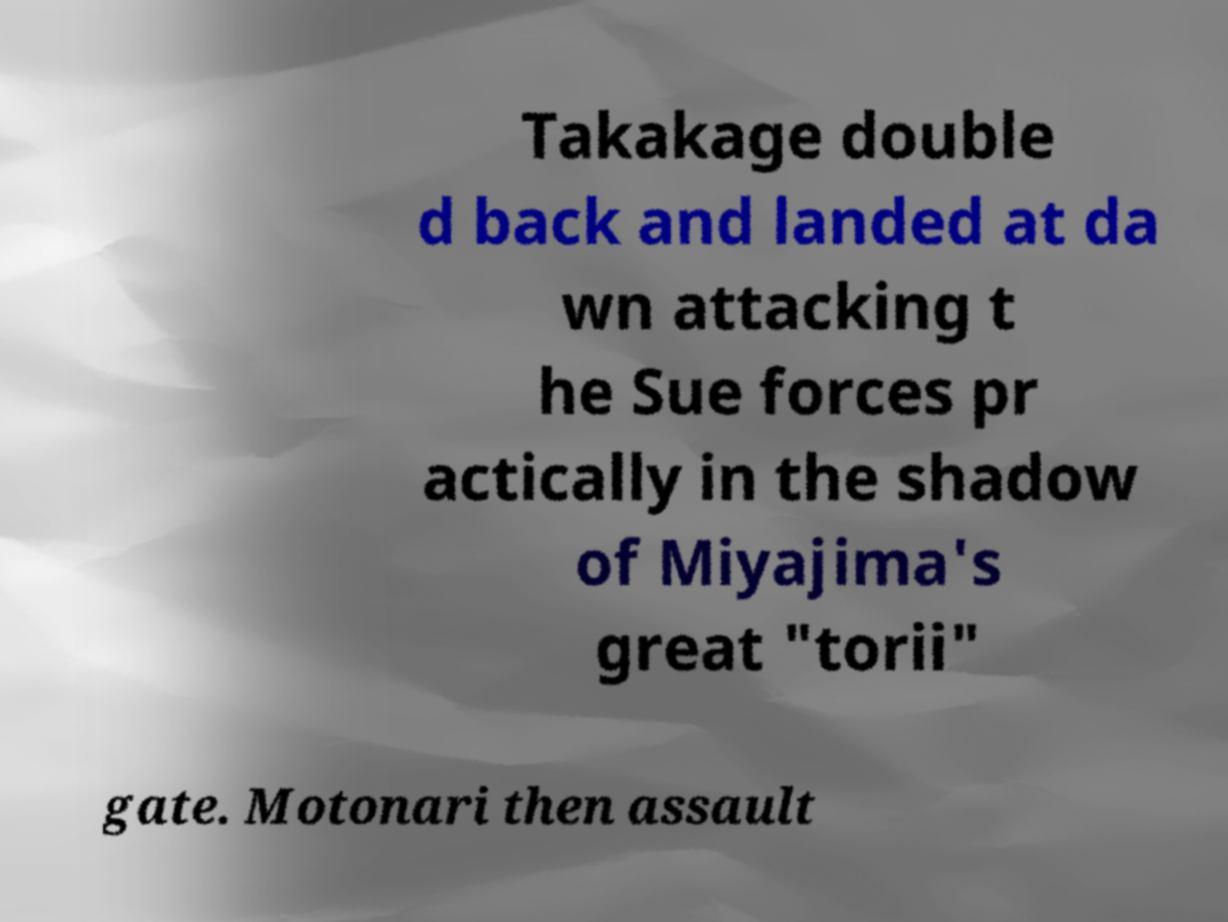Please read and relay the text visible in this image. What does it say? Takakage double d back and landed at da wn attacking t he Sue forces pr actically in the shadow of Miyajima's great "torii" gate. Motonari then assault 